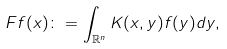<formula> <loc_0><loc_0><loc_500><loc_500>F f ( x ) \colon = \int _ { \mathbb { R } ^ { n } } K ( x , y ) f ( y ) d y , \,</formula> 